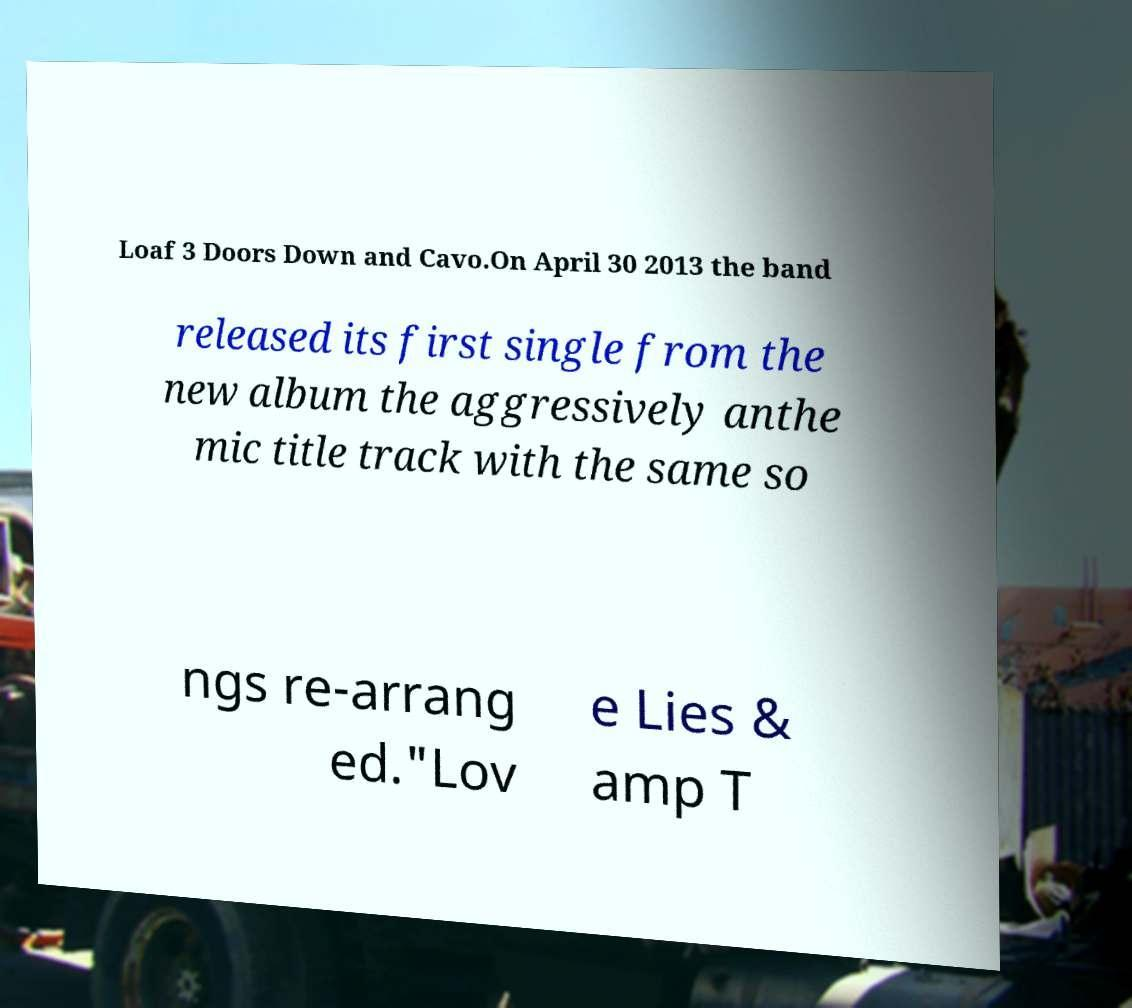Can you accurately transcribe the text from the provided image for me? Loaf 3 Doors Down and Cavo.On April 30 2013 the band released its first single from the new album the aggressively anthe mic title track with the same so ngs re-arrang ed."Lov e Lies & amp T 